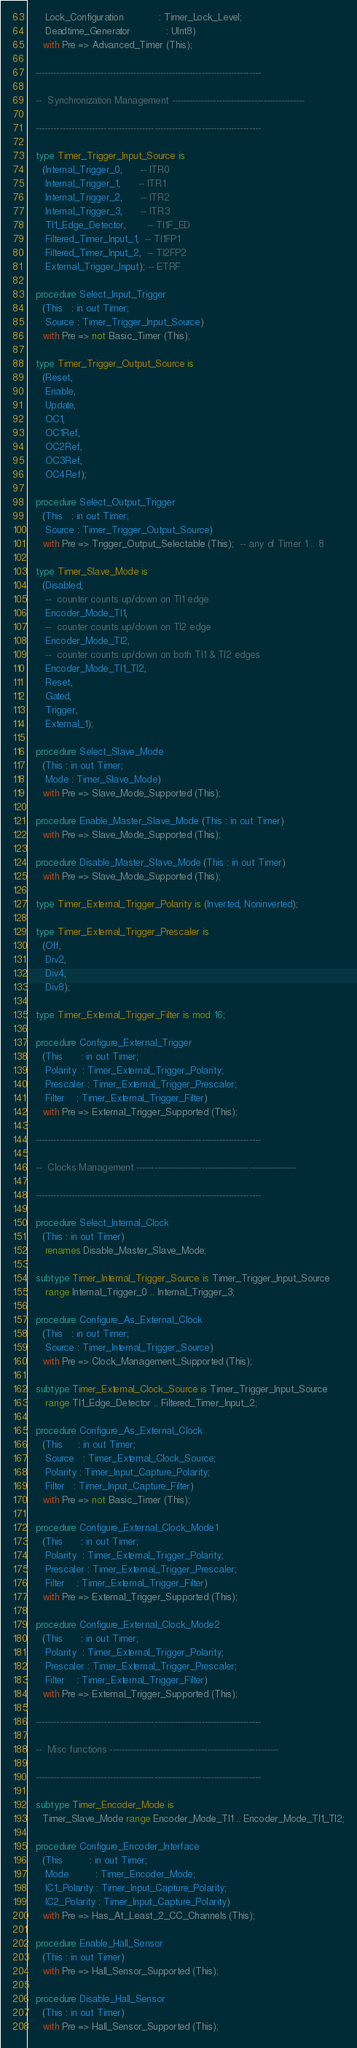<code> <loc_0><loc_0><loc_500><loc_500><_Ada_>      Lock_Configuration            : Timer_Lock_Level;
      Deadtime_Generator            : UInt8)
     with Pre => Advanced_Timer (This);

   ----------------------------------------------------------------------------

   --  Synchronization Management ---------------------------------------------

   ----------------------------------------------------------------------------

   type Timer_Trigger_Input_Source is
     (Internal_Trigger_0,      -- ITR0
      Internal_Trigger_1,      -- ITR1
      Internal_Trigger_2,      -- ITR2
      Internal_Trigger_3,      -- ITR3
      TI1_Edge_Detector,       -- TI1F_ED
      Filtered_Timer_Input_1,  -- TI1FP1
      Filtered_Timer_Input_2,  -- TI2FP2
      External_Trigger_Input); -- ETRF

   procedure Select_Input_Trigger
     (This   : in out Timer;
      Source : Timer_Trigger_Input_Source)
     with Pre => not Basic_Timer (This);

   type Timer_Trigger_Output_Source is
     (Reset,
      Enable,
      Update,
      OC1,
      OC1Ref,
      OC2Ref,
      OC3Ref,
      OC4Ref);

   procedure Select_Output_Trigger
     (This   : in out Timer;
      Source : Timer_Trigger_Output_Source)
     with Pre => Trigger_Output_Selectable (This);  -- any of Timer 1 .. 8

   type Timer_Slave_Mode is
     (Disabled,
      --  counter counts up/down on TI1 edge
      Encoder_Mode_TI1,
      --  counter counts up/down on TI2 edge
      Encoder_Mode_TI2,
      --  counter counts up/down on both TI1 & TI2 edges
      Encoder_Mode_TI1_TI2,
      Reset,
      Gated,
      Trigger,
      External_1);

   procedure Select_Slave_Mode
     (This : in out Timer;
      Mode : Timer_Slave_Mode)
     with Pre => Slave_Mode_Supported (This);

   procedure Enable_Master_Slave_Mode (This : in out Timer)
     with Pre => Slave_Mode_Supported (This);

   procedure Disable_Master_Slave_Mode (This : in out Timer)
     with Pre => Slave_Mode_Supported (This);

   type Timer_External_Trigger_Polarity is (Inverted, Noninverted);

   type Timer_External_Trigger_Prescaler is
     (Off,
      Div2,
      Div4,
      Div8);

   type Timer_External_Trigger_Filter is mod 16;

   procedure Configure_External_Trigger
     (This      : in out Timer;
      Polarity  : Timer_External_Trigger_Polarity;
      Prescaler : Timer_External_Trigger_Prescaler;
      Filter    : Timer_External_Trigger_Filter)
     with Pre => External_Trigger_Supported (This);

   ----------------------------------------------------------------------------

   --  Clocks Management ------------------------------------------------------

   ----------------------------------------------------------------------------

   procedure Select_Internal_Clock
     (This : in out Timer)
      renames Disable_Master_Slave_Mode;

   subtype Timer_Internal_Trigger_Source is Timer_Trigger_Input_Source
      range Internal_Trigger_0 .. Internal_Trigger_3;

   procedure Configure_As_External_Clock
     (This   : in out Timer;
      Source : Timer_Internal_Trigger_Source)
     with Pre => Clock_Management_Supported (This);

   subtype Timer_External_Clock_Source is Timer_Trigger_Input_Source
      range TI1_Edge_Detector .. Filtered_Timer_Input_2;

   procedure Configure_As_External_Clock
     (This     : in out Timer;
      Source   : Timer_External_Clock_Source;
      Polarity : Timer_Input_Capture_Polarity;
      Filter   : Timer_Input_Capture_Filter)
     with Pre => not Basic_Timer (This);

   procedure Configure_External_Clock_Mode1
     (This      : in out Timer;
      Polarity  : Timer_External_Trigger_Polarity;
      Prescaler : Timer_External_Trigger_Prescaler;
      Filter    : Timer_External_Trigger_Filter)
     with Pre => External_Trigger_Supported (This);

   procedure Configure_External_Clock_Mode2
     (This      : in out Timer;
      Polarity  : Timer_External_Trigger_Polarity;
      Prescaler : Timer_External_Trigger_Prescaler;
      Filter    : Timer_External_Trigger_Filter)
     with Pre => External_Trigger_Supported (This);

   ----------------------------------------------------------------------------

   --  Misc functions ---------------------------------------------------------

   ----------------------------------------------------------------------------

   subtype Timer_Encoder_Mode is
     Timer_Slave_Mode range Encoder_Mode_TI1 .. Encoder_Mode_TI1_TI2;

   procedure Configure_Encoder_Interface
     (This         : in out Timer;
      Mode         : Timer_Encoder_Mode;
      IC1_Polarity : Timer_Input_Capture_Polarity;
      IC2_Polarity : Timer_Input_Capture_Polarity)
     with Pre => Has_At_Least_2_CC_Channels (This);

   procedure Enable_Hall_Sensor
     (This : in out Timer)
     with Pre => Hall_Sensor_Supported (This);

   procedure Disable_Hall_Sensor
     (This : in out Timer)
     with Pre => Hall_Sensor_Supported (This);
</code> 